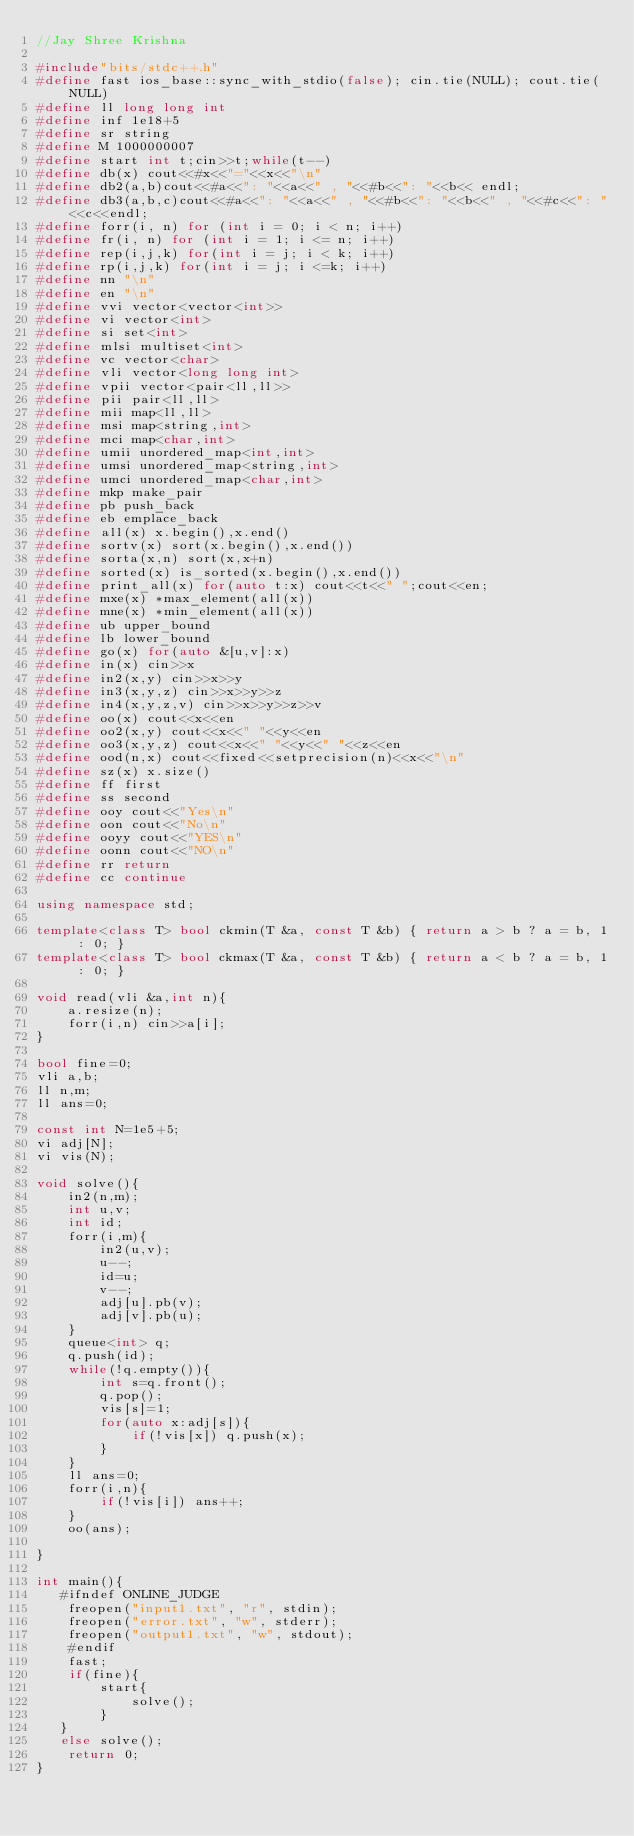Convert code to text. <code><loc_0><loc_0><loc_500><loc_500><_C++_>//Jay Shree Krishna

#include"bits/stdc++.h"
#define fast ios_base::sync_with_stdio(false); cin.tie(NULL); cout.tie(NULL)
#define ll long long int
#define inf 1e18+5
#define sr string
#define M 1000000007
#define start int t;cin>>t;while(t--)
#define db(x) cout<<#x<<"="<<x<<"\n"
#define db2(a,b)cout<<#a<<": "<<a<<" , "<<#b<<": "<<b<< endl;
#define db3(a,b,c)cout<<#a<<": "<<a<<" , "<<#b<<": "<<b<<" , "<<#c<<": "<<c<<endl;
#define forr(i, n) for (int i = 0; i < n; i++)
#define fr(i, n) for (int i = 1; i <= n; i++)
#define rep(i,j,k) for(int i = j; i < k; i++)
#define rp(i,j,k) for(int i = j; i <=k; i++)
#define nn "\n"
#define en "\n"
#define vvi vector<vector<int>>
#define vi vector<int>
#define si set<int>
#define mlsi multiset<int>
#define vc vector<char>
#define vli vector<long long int>
#define vpii vector<pair<ll,ll>>
#define pii pair<ll,ll>
#define mii map<ll,ll>
#define msi map<string,int>
#define mci map<char,int>
#define umii unordered_map<int,int>
#define umsi unordered_map<string,int>
#define umci unordered_map<char,int>
#define mkp make_pair
#define pb push_back
#define eb emplace_back
#define all(x) x.begin(),x.end()
#define sortv(x) sort(x.begin(),x.end())
#define sorta(x,n) sort(x,x+n)
#define sorted(x) is_sorted(x.begin(),x.end())
#define print_all(x) for(auto t:x) cout<<t<<" ";cout<<en;
#define mxe(x) *max_element(all(x))
#define mne(x) *min_element(all(x))
#define ub upper_bound
#define lb lower_bound
#define go(x) for(auto &[u,v]:x)
#define in(x) cin>>x
#define in2(x,y) cin>>x>>y
#define in3(x,y,z) cin>>x>>y>>z
#define in4(x,y,z,v) cin>>x>>y>>z>>v
#define oo(x) cout<<x<<en
#define oo2(x,y) cout<<x<<" "<<y<<en
#define oo3(x,y,z) cout<<x<<" "<<y<<" "<<z<<en
#define ood(n,x) cout<<fixed<<setprecision(n)<<x<<"\n"
#define sz(x) x.size()
#define ff first
#define ss second
#define ooy cout<<"Yes\n"
#define oon cout<<"No\n"
#define ooyy cout<<"YES\n"
#define oonn cout<<"NO\n" 
#define rr return
#define cc continue

using namespace std;

template<class T> bool ckmin(T &a, const T &b) { return a > b ? a = b, 1 : 0; }
template<class T> bool ckmax(T &a, const T &b) { return a < b ? a = b, 1 : 0; }
 
void read(vli &a,int n){
    a.resize(n);
    forr(i,n) cin>>a[i];
}

bool fine=0;
vli a,b;
ll n,m;
ll ans=0;

const int N=1e5+5;
vi adj[N];
vi vis(N);

void solve(){
    in2(n,m);
    int u,v;
    int id;
    forr(i,m){
        in2(u,v);
        u--;
        id=u;
        v--;
        adj[u].pb(v);
        adj[v].pb(u);
    }
    queue<int> q;
    q.push(id);
    while(!q.empty()){
        int s=q.front();
        q.pop();
        vis[s]=1;
        for(auto x:adj[s]){
            if(!vis[x]) q.push(x);
        }
    }
    ll ans=0;
    forr(i,n){
        if(!vis[i]) ans++;
    }
    oo(ans);

}

int main(){
   #ifndef ONLINE_JUDGE 
    freopen("input1.txt", "r", stdin); 
    freopen("error.txt", "w", stderr); 
    freopen("output1.txt", "w", stdout); 
    #endif
    fast;
    if(fine){
        start{
            solve();
        }
   }
   else solve();
    return 0;
}
</code> 